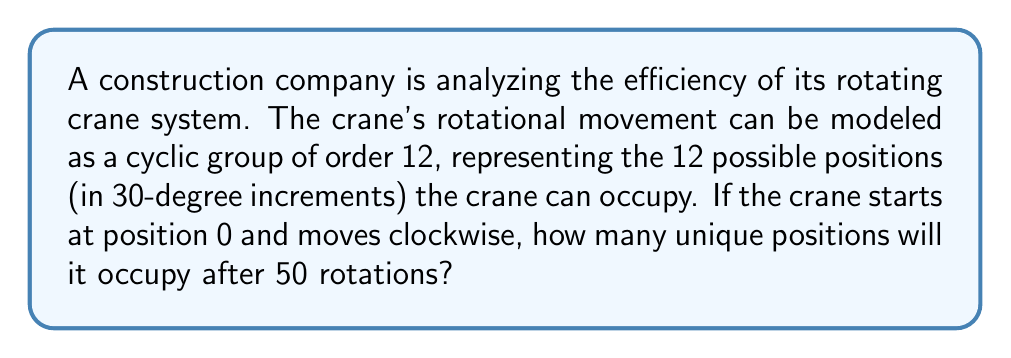Help me with this question. To solve this problem, we can use concepts from ring theory, specifically cyclic groups and modular arithmetic.

1) First, we recognize that the crane's movement forms a cyclic group of order 12, which we can represent as $\mathbb{Z}_{12}$ (the integers modulo 12).

2) Each clockwise rotation moves the crane one position forward. So after 50 rotations, the crane will have moved 50 positions.

3) To find the final position, we need to compute $50 \pmod{12}$. This is equivalent to finding the remainder when 50 is divided by 12.

4) We can perform this calculation:
   
   $50 = 4 \times 12 + 2$

5) Therefore, $50 \equiv 2 \pmod{12}$

6) This means that after 50 rotations, the crane will be in position 2 (60 degrees clockwise from the starting position).

7) To find how many unique positions the crane occupied, we need to determine the order of the element 1 in $\mathbb{Z}_{12}$.

8) The order of 1 in $\mathbb{Z}_{12}$ is 12, as $1 \cdot 12 \equiv 0 \pmod{12}$ is the smallest positive integer that satisfies this congruence.

9) Since the order is 12, the crane will occupy all 12 possible positions before repeating.

Therefore, the crane will occupy all 12 unique positions during its 50 rotations.
Answer: 12 unique positions 